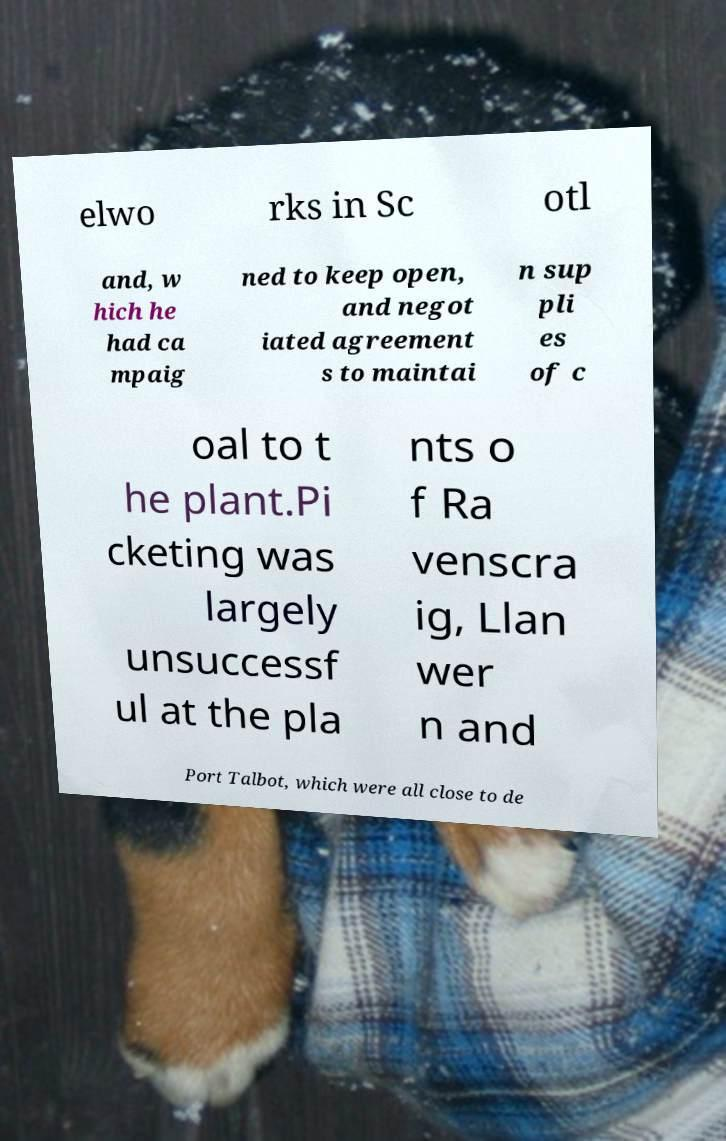Please identify and transcribe the text found in this image. elwo rks in Sc otl and, w hich he had ca mpaig ned to keep open, and negot iated agreement s to maintai n sup pli es of c oal to t he plant.Pi cketing was largely unsuccessf ul at the pla nts o f Ra venscra ig, Llan wer n and Port Talbot, which were all close to de 